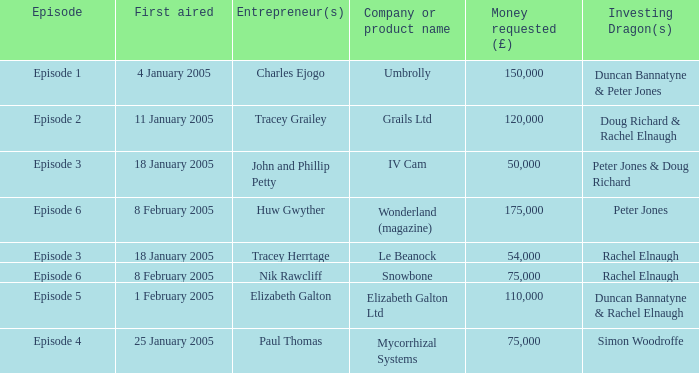Who were the Investing Dragons in the episode that first aired on 18 January 2005 with the entrepreneur Tracey Herrtage? Rachel Elnaugh. 